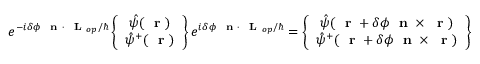<formula> <loc_0><loc_0><loc_500><loc_500>e ^ { - i \delta \phi n \cdot L _ { o p } / } \left \{ \begin{array} { c } { \hat { \psi } ( r ) } \\ { \hat { \psi } ^ { + } ( r ) } \end{array} \right \} e ^ { i \delta \phi n \cdot L _ { o p } / } = \left \{ \begin{array} { c } { \hat { \psi } ( r + \delta \phi n \times r ) } \\ { \hat { \psi } ^ { + } ( r + \delta \phi n \times r ) } \end{array} \right \}</formula> 